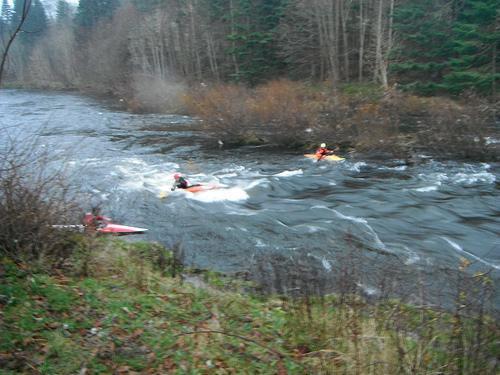How many people are in the kayak?
Give a very brief answer. 3. 